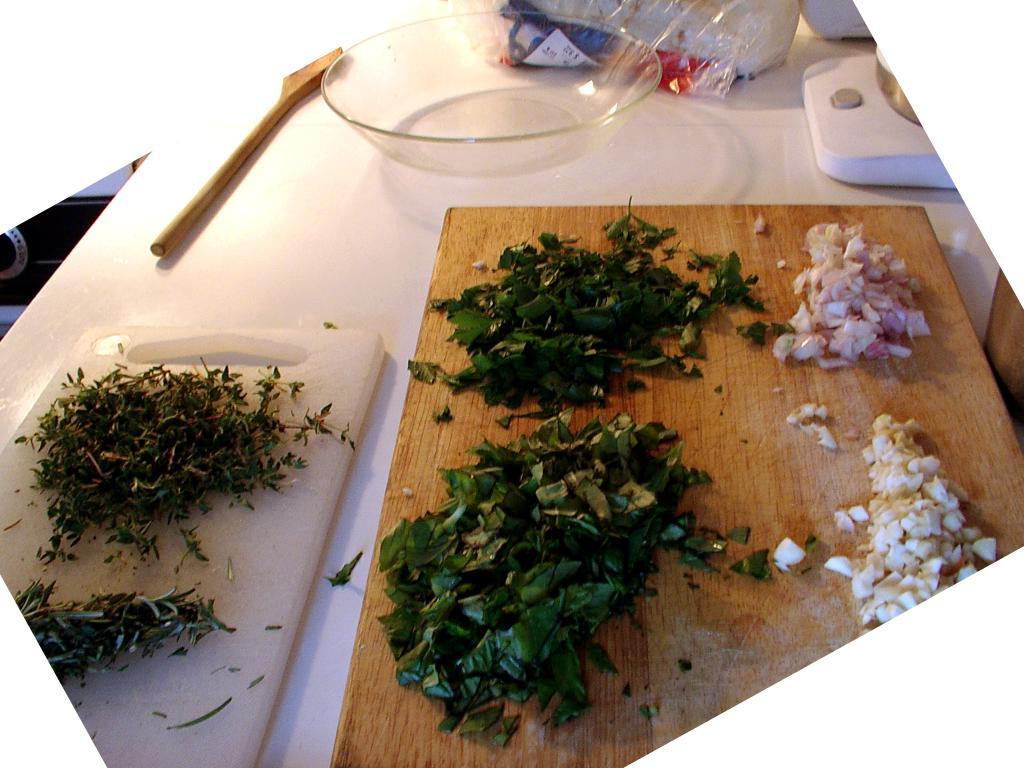What is placed on the chopping boards in the image? There are pieces of leaves on chopping boards in the image. What container is present in the image? There is a bowl in the image. What type of utensil can be seen in the image? There is a wooden stick in the image. What is the color of the surface where other objects are placed? There are other objects on a white color surface in the image. What type of insect is crawling on the ground in the image? There is no insect present in the image, and the ground is not visible in the image. What authority figure can be seen in the image? There is no authority figure present in the image. 